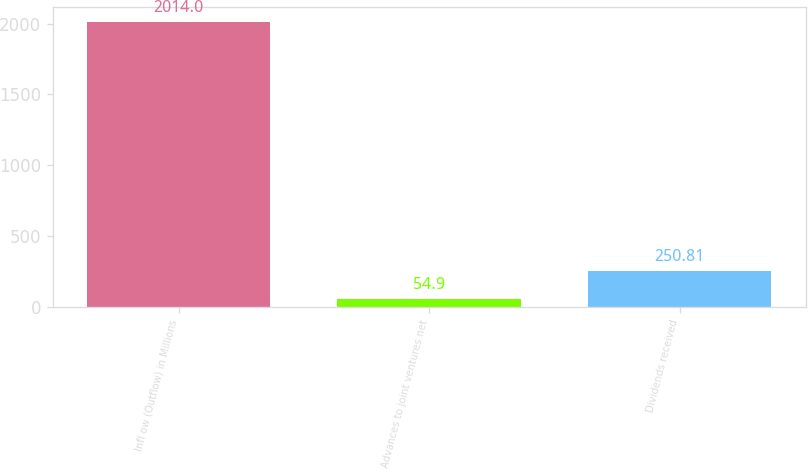Convert chart to OTSL. <chart><loc_0><loc_0><loc_500><loc_500><bar_chart><fcel>Infl ow (Outflow) in Millions<fcel>Advances to joint ventures net<fcel>Dividends received<nl><fcel>2014<fcel>54.9<fcel>250.81<nl></chart> 